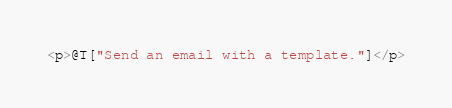Convert code to text. <code><loc_0><loc_0><loc_500><loc_500><_C#_><p>@T["Send an email with a template."]</p>
</code> 